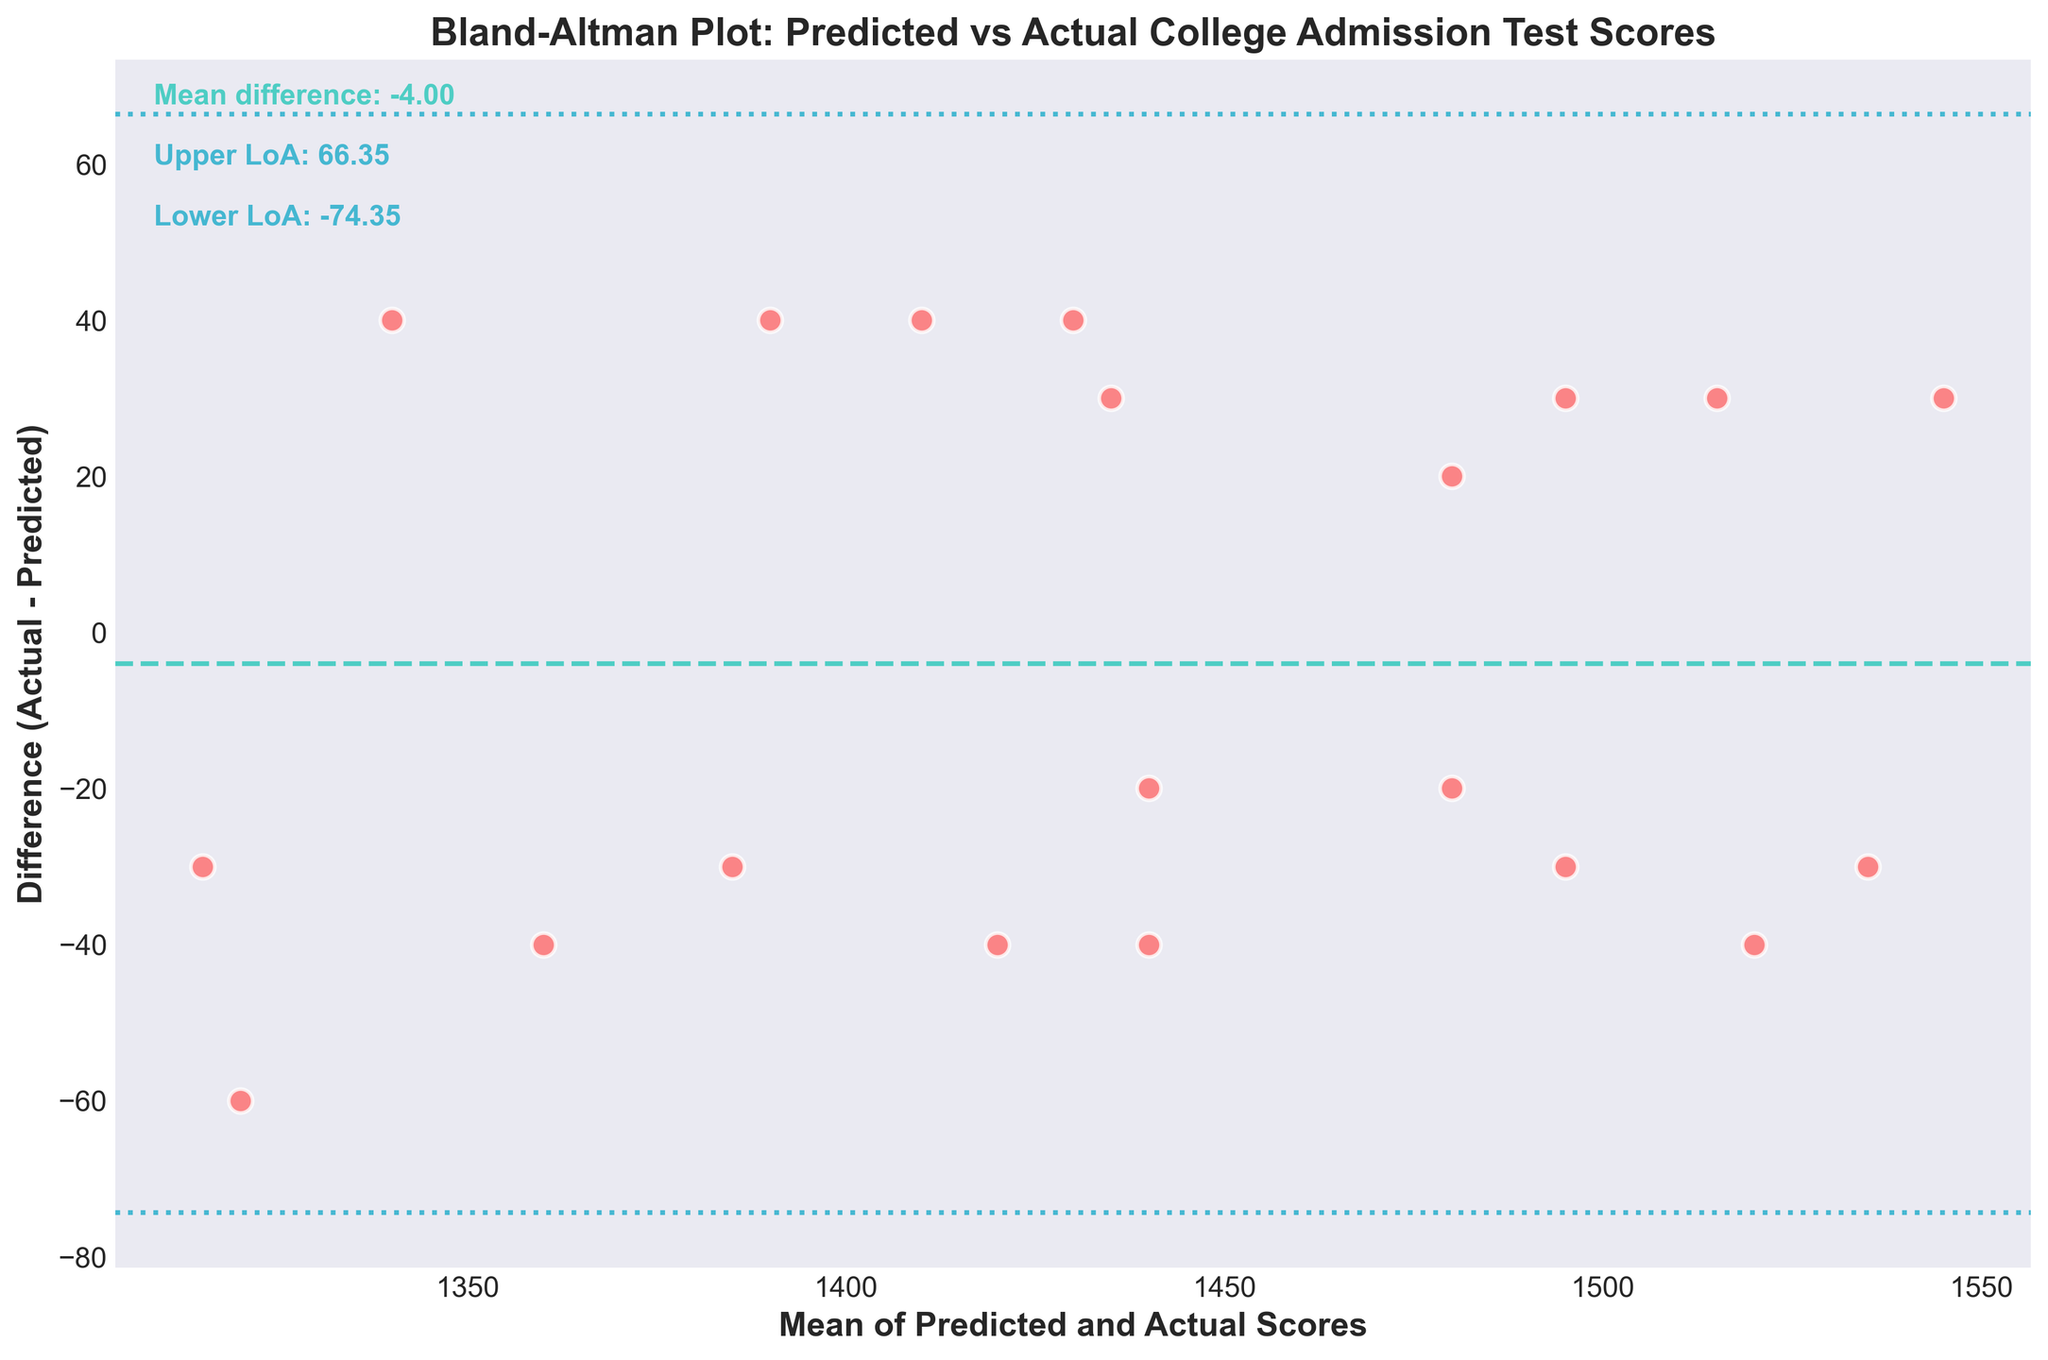What is the main title of the figure? The main title of the figure is usually displayed at the top and describes the content of the plot. In this case, it summarizes the comparison of predicted versus actual scores.
Answer: Bland-Altman Plot: Predicted vs Actual College Admission Test Scores What do the X and Y axes represent? The labels on the X and Y axes indicate what is being plotted. The X-axis shows the mean of predicted and actual scores, while the Y-axis shows the difference between actual and predicted scores.
Answer: Mean of Predicted and Actual Scores (X), Difference (Actual - Predicted) (Y) How many data points are shown in the plot? Each point in the scatter plot represents one student's test scores. Counting these points will give the total number of students.
Answer: 20 What is the mean difference between actual and predicted scores? The mean difference between actual and predicted scores is usually annotated on the plot, often as a horizontal line intersecting the Y-axis at this value.
Answer: ~0.50 What are the upper and lower limits of agreement (LoA)? The limits of agreement are shown as dashed lines and are usually annotated with their numerical values on the plot. These define the range within which most differences will lie.
Answer: Upper LoA: ~44.10, Lower LoA: ~-43.10 Which student has the largest positive difference between actual and predicted scores? This can be determined by finding the highest point above the X-axis. The student represented by this point has the largest positive difference.
Answer: Emily Johnson (difference = +30) Which student has the largest negative difference between actual and predicted scores? This can be determined by finding the lowest point below the X-axis. The student represented by this point has the largest negative difference.
Answer: Ryan Murphy (difference = -40) How many students have a difference within the limits of agreement? Count the number of data points that fall between the upper and lower limits of agreement lines.
Answer: 19 What is the average of the mean scores (X-axis) for the students? The average mean score is the sum of all mean scores divided by the number of students. First, add all mean scores and then divide by the total number of data points.
Answer: ~1450 Are there more students whose actual scores are higher than predicted, or whose actual scores are lower? By comparing the number of points above and below the horizontal line at zero difference on the Y-axis, we can determine if more students have higher or lower actual scores than predicted.
Answer: More students have higher actual scores 